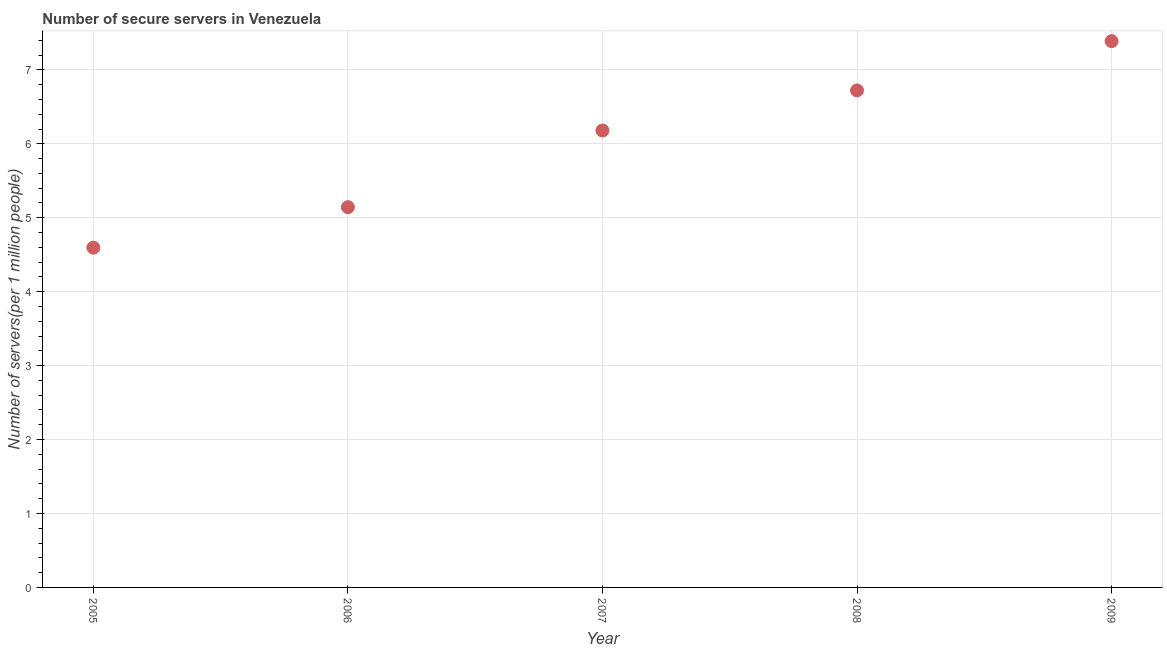What is the number of secure internet servers in 2008?
Offer a terse response. 6.72. Across all years, what is the maximum number of secure internet servers?
Keep it short and to the point. 7.39. Across all years, what is the minimum number of secure internet servers?
Your answer should be very brief. 4.59. In which year was the number of secure internet servers minimum?
Make the answer very short. 2005. What is the sum of the number of secure internet servers?
Your answer should be compact. 30.03. What is the difference between the number of secure internet servers in 2005 and 2009?
Make the answer very short. -2.79. What is the average number of secure internet servers per year?
Offer a very short reply. 6.01. What is the median number of secure internet servers?
Your response must be concise. 6.18. What is the ratio of the number of secure internet servers in 2005 to that in 2008?
Your answer should be compact. 0.68. What is the difference between the highest and the second highest number of secure internet servers?
Offer a terse response. 0.67. Is the sum of the number of secure internet servers in 2007 and 2009 greater than the maximum number of secure internet servers across all years?
Your response must be concise. Yes. What is the difference between the highest and the lowest number of secure internet servers?
Your answer should be very brief. 2.79. In how many years, is the number of secure internet servers greater than the average number of secure internet servers taken over all years?
Offer a terse response. 3. Are the values on the major ticks of Y-axis written in scientific E-notation?
Make the answer very short. No. What is the title of the graph?
Give a very brief answer. Number of secure servers in Venezuela. What is the label or title of the Y-axis?
Provide a succinct answer. Number of servers(per 1 million people). What is the Number of servers(per 1 million people) in 2005?
Make the answer very short. 4.59. What is the Number of servers(per 1 million people) in 2006?
Offer a very short reply. 5.14. What is the Number of servers(per 1 million people) in 2007?
Offer a very short reply. 6.18. What is the Number of servers(per 1 million people) in 2008?
Give a very brief answer. 6.72. What is the Number of servers(per 1 million people) in 2009?
Your response must be concise. 7.39. What is the difference between the Number of servers(per 1 million people) in 2005 and 2006?
Your response must be concise. -0.55. What is the difference between the Number of servers(per 1 million people) in 2005 and 2007?
Offer a terse response. -1.58. What is the difference between the Number of servers(per 1 million people) in 2005 and 2008?
Your response must be concise. -2.13. What is the difference between the Number of servers(per 1 million people) in 2005 and 2009?
Your answer should be compact. -2.79. What is the difference between the Number of servers(per 1 million people) in 2006 and 2007?
Your answer should be compact. -1.04. What is the difference between the Number of servers(per 1 million people) in 2006 and 2008?
Offer a terse response. -1.58. What is the difference between the Number of servers(per 1 million people) in 2006 and 2009?
Your answer should be compact. -2.25. What is the difference between the Number of servers(per 1 million people) in 2007 and 2008?
Keep it short and to the point. -0.54. What is the difference between the Number of servers(per 1 million people) in 2007 and 2009?
Provide a succinct answer. -1.21. What is the difference between the Number of servers(per 1 million people) in 2008 and 2009?
Keep it short and to the point. -0.67. What is the ratio of the Number of servers(per 1 million people) in 2005 to that in 2006?
Your response must be concise. 0.89. What is the ratio of the Number of servers(per 1 million people) in 2005 to that in 2007?
Your answer should be very brief. 0.74. What is the ratio of the Number of servers(per 1 million people) in 2005 to that in 2008?
Make the answer very short. 0.68. What is the ratio of the Number of servers(per 1 million people) in 2005 to that in 2009?
Your answer should be very brief. 0.62. What is the ratio of the Number of servers(per 1 million people) in 2006 to that in 2007?
Your response must be concise. 0.83. What is the ratio of the Number of servers(per 1 million people) in 2006 to that in 2008?
Ensure brevity in your answer.  0.77. What is the ratio of the Number of servers(per 1 million people) in 2006 to that in 2009?
Provide a succinct answer. 0.7. What is the ratio of the Number of servers(per 1 million people) in 2007 to that in 2008?
Provide a short and direct response. 0.92. What is the ratio of the Number of servers(per 1 million people) in 2007 to that in 2009?
Offer a very short reply. 0.84. What is the ratio of the Number of servers(per 1 million people) in 2008 to that in 2009?
Give a very brief answer. 0.91. 